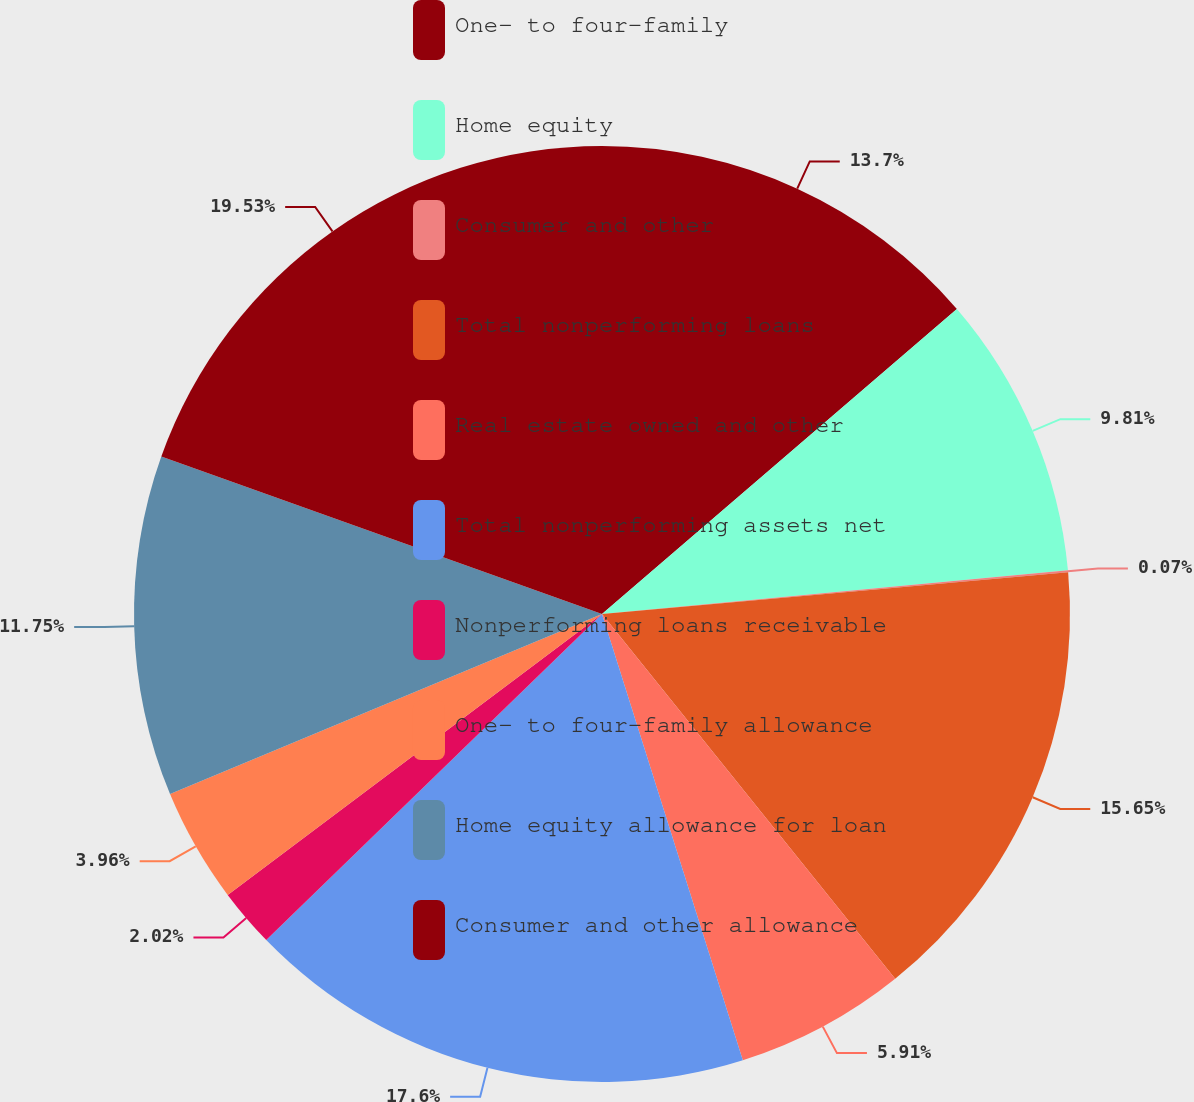Convert chart. <chart><loc_0><loc_0><loc_500><loc_500><pie_chart><fcel>One- to four-family<fcel>Home equity<fcel>Consumer and other<fcel>Total nonperforming loans<fcel>Real estate owned and other<fcel>Total nonperforming assets net<fcel>Nonperforming loans receivable<fcel>One- to four-family allowance<fcel>Home equity allowance for loan<fcel>Consumer and other allowance<nl><fcel>13.7%<fcel>9.81%<fcel>0.07%<fcel>15.65%<fcel>5.91%<fcel>17.6%<fcel>2.02%<fcel>3.96%<fcel>11.75%<fcel>19.54%<nl></chart> 